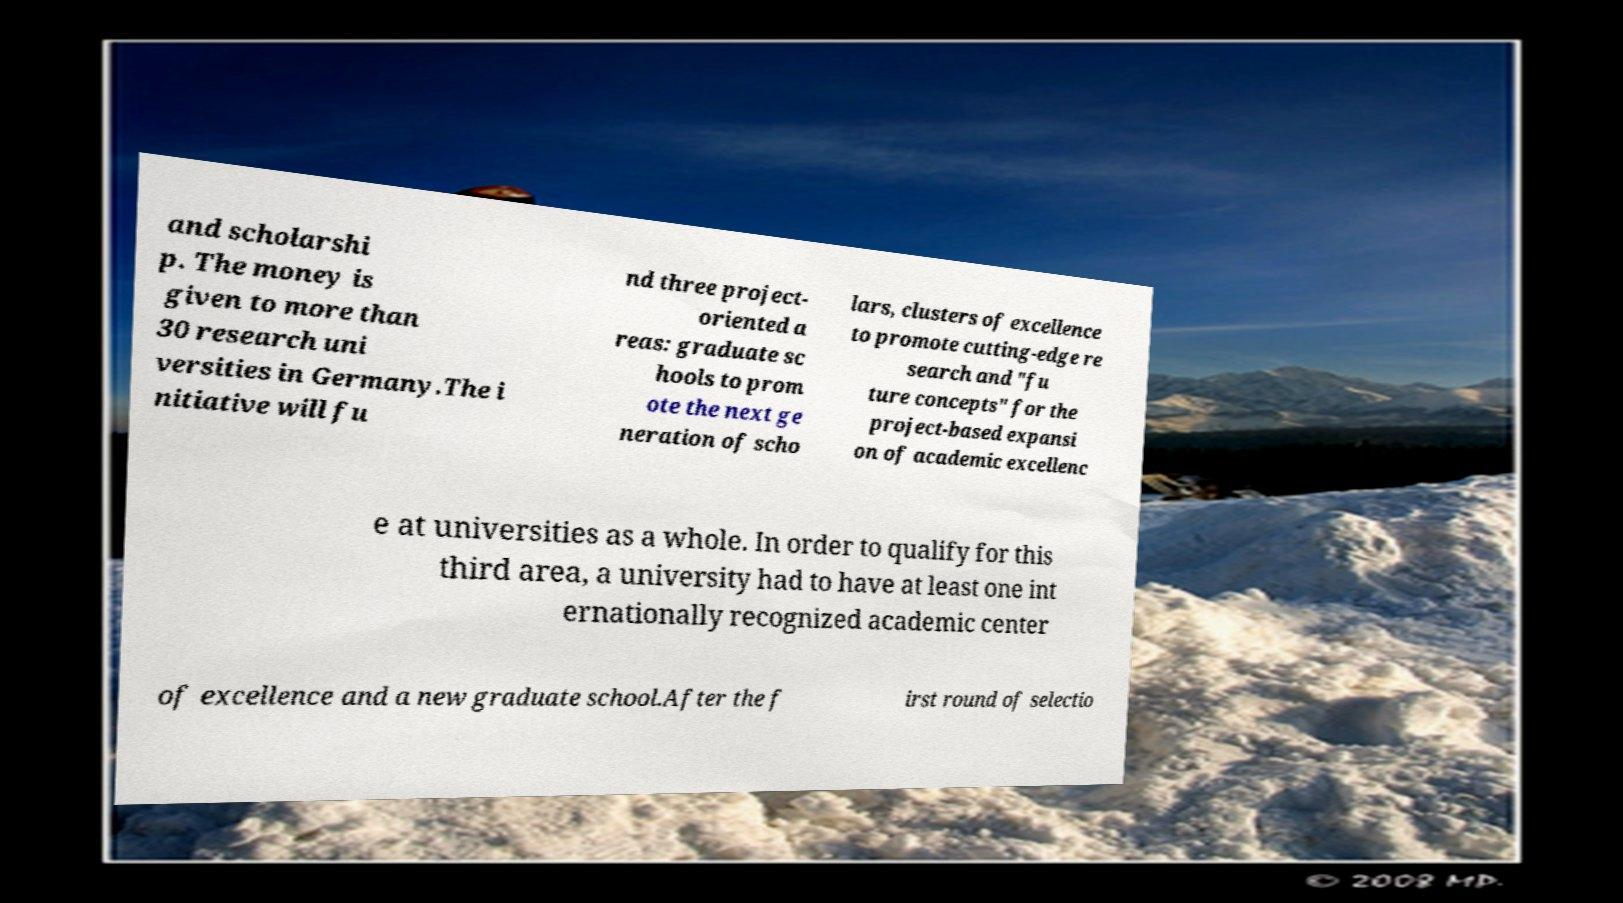Could you extract and type out the text from this image? and scholarshi p. The money is given to more than 30 research uni versities in Germany.The i nitiative will fu nd three project- oriented a reas: graduate sc hools to prom ote the next ge neration of scho lars, clusters of excellence to promote cutting-edge re search and "fu ture concepts" for the project-based expansi on of academic excellenc e at universities as a whole. In order to qualify for this third area, a university had to have at least one int ernationally recognized academic center of excellence and a new graduate school.After the f irst round of selectio 